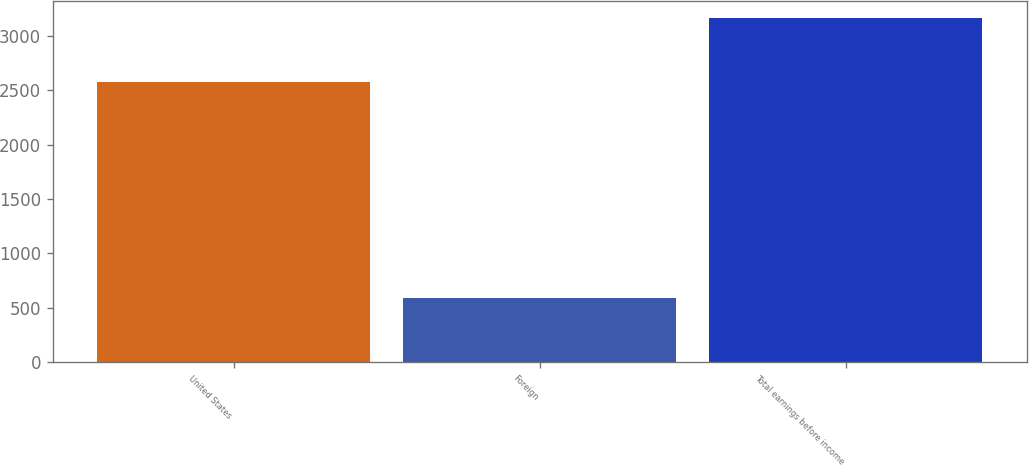Convert chart. <chart><loc_0><loc_0><loc_500><loc_500><bar_chart><fcel>United States<fcel>Foreign<fcel>Total earnings before income<nl><fcel>2572.4<fcel>587.3<fcel>3159.7<nl></chart> 